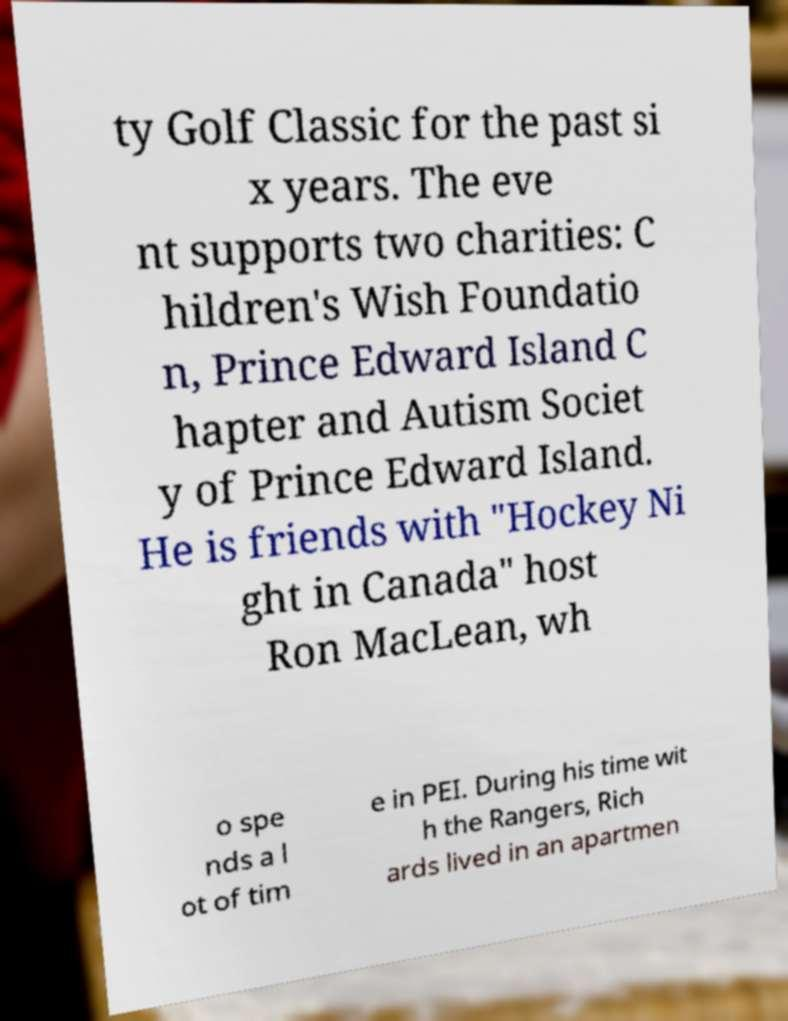There's text embedded in this image that I need extracted. Can you transcribe it verbatim? ty Golf Classic for the past si x years. The eve nt supports two charities: C hildren's Wish Foundatio n, Prince Edward Island C hapter and Autism Societ y of Prince Edward Island. He is friends with "Hockey Ni ght in Canada" host Ron MacLean, wh o spe nds a l ot of tim e in PEI. During his time wit h the Rangers, Rich ards lived in an apartmen 